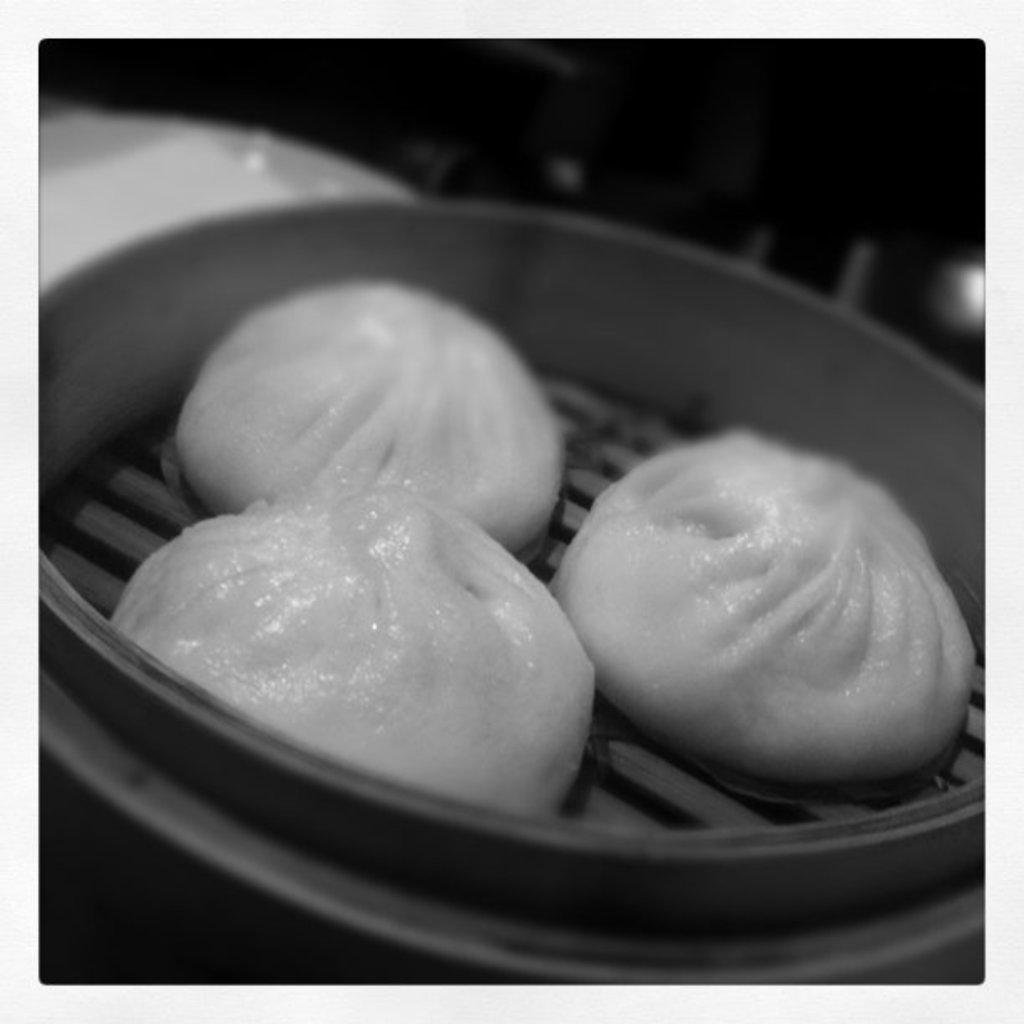What type of wound can be seen healing on the earth in the image? There is no wound or earth present in the image, and therefore no such activity can be observed. What type of bells can be heard ringing in the image? There are no bells present in the image, and therefore no such sound can be heard. 